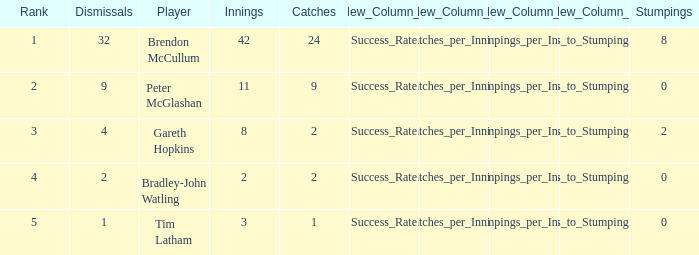List the ranks of all dismissals with a value of 4 3.0. 